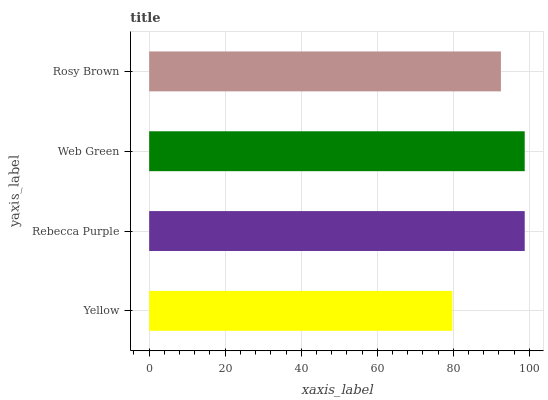Is Yellow the minimum?
Answer yes or no. Yes. Is Rebecca Purple the maximum?
Answer yes or no. Yes. Is Web Green the minimum?
Answer yes or no. No. Is Web Green the maximum?
Answer yes or no. No. Is Rebecca Purple greater than Web Green?
Answer yes or no. Yes. Is Web Green less than Rebecca Purple?
Answer yes or no. Yes. Is Web Green greater than Rebecca Purple?
Answer yes or no. No. Is Rebecca Purple less than Web Green?
Answer yes or no. No. Is Web Green the high median?
Answer yes or no. Yes. Is Rosy Brown the low median?
Answer yes or no. Yes. Is Rebecca Purple the high median?
Answer yes or no. No. Is Rebecca Purple the low median?
Answer yes or no. No. 